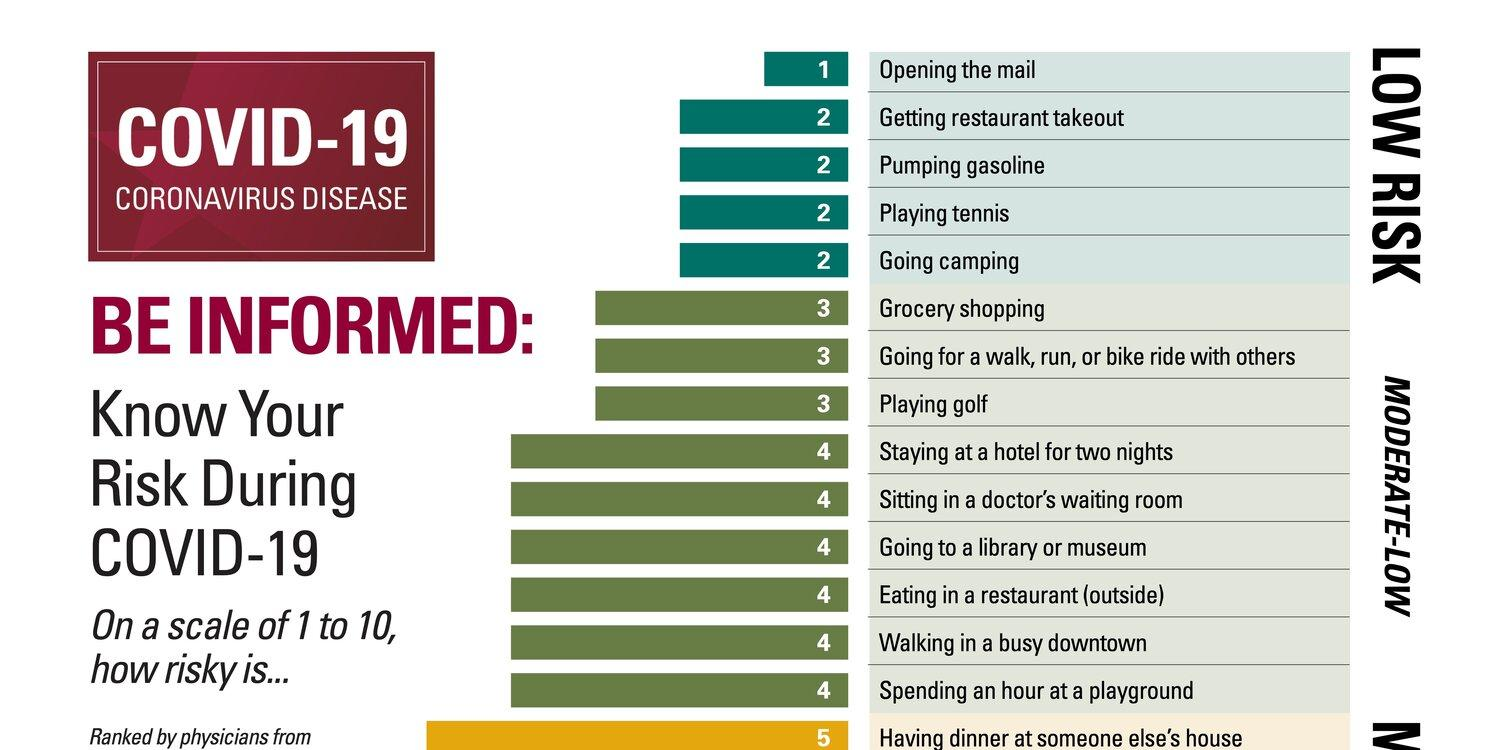Point out several critical features in this image. There are five actions that are considered to be at low risk. There were four actions with a risk factor of 2. There were six actions with a risk factor of 4. There were 1 action with a risk factor of 5. There are 9 actions that are considered to be at moderate-low risk. 